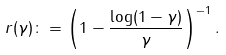<formula> <loc_0><loc_0><loc_500><loc_500>r ( \gamma ) \colon = \left ( 1 - \frac { \log ( 1 - \gamma ) } { \gamma } \right ) ^ { - 1 } .</formula> 